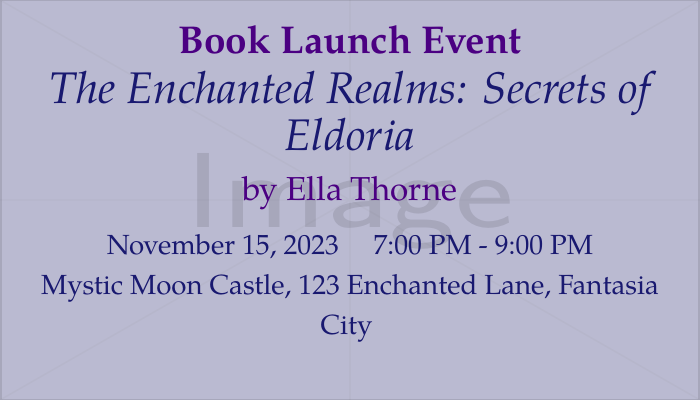What is the title of the book being launched? The title of the book is clearly stated in the document.
Answer: The Enchanted Realms: Secrets of Eldoria Who is the author of the book? The author's name is mentioned near the title of the book.
Answer: Ella Thorne What is the date of the book launch event? The event date is specified in the document under the date section.
Answer: November 15, 2023 What time will the book launch party start? The start time is listed in the details of the event.
Answer: 7:00 PM What is the venue for the event? The venue name and address are provided in the document.
Answer: Mystic Moon Castle, 123 Enchanted Lane, Fantasia City What is the RSVP email address? This information is specifically provided for attendees to confirm their attendance.
Answer: RSVP@ellathornebooks.com What special activity will take place during the event? The document lists specific activities featured at the event.
Answer: Exclusive Reading How many special guests are mentioned? The document lists the names of special guests explicitly.
Answer: Two What is the color theme used in the document design? The document states specific color choices used in the design and text.
Answer: Midnight blue and deep violet 